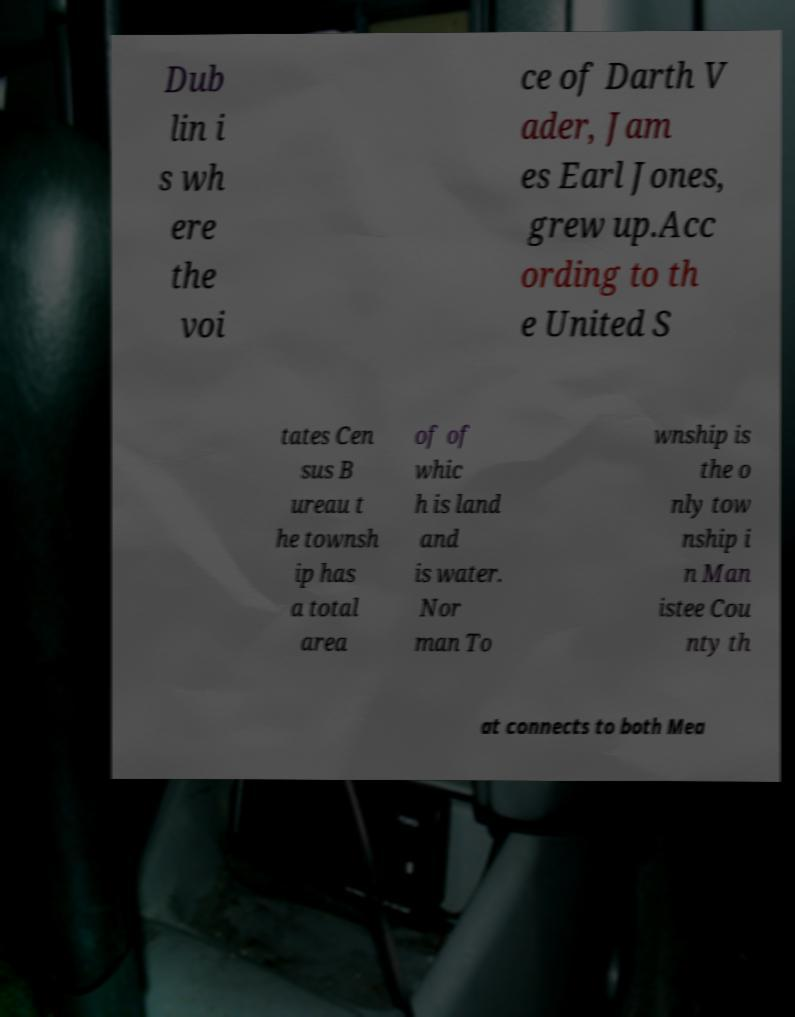I need the written content from this picture converted into text. Can you do that? Dub lin i s wh ere the voi ce of Darth V ader, Jam es Earl Jones, grew up.Acc ording to th e United S tates Cen sus B ureau t he townsh ip has a total area of of whic h is land and is water. Nor man To wnship is the o nly tow nship i n Man istee Cou nty th at connects to both Mea 